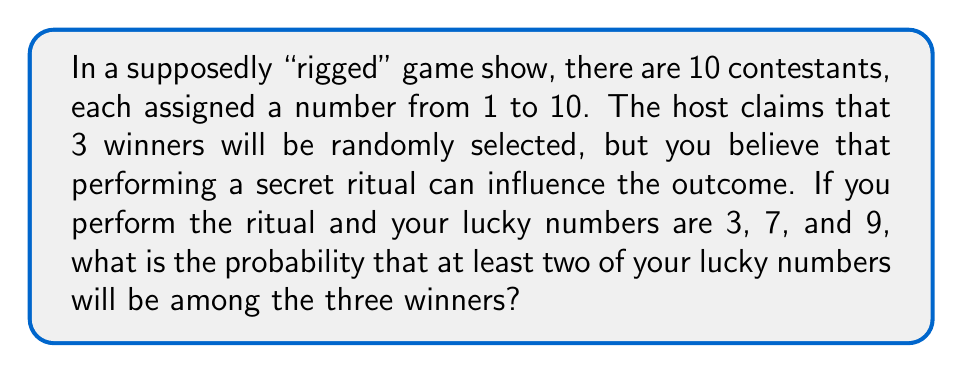Can you answer this question? Let's approach this step-by-step using combinatorics:

1) First, we need to calculate the total number of possible ways to select 3 winners out of 10 contestants. This is given by the combination formula:

   $$\binom{10}{3} = \frac{10!}{3!(10-3)!} = \frac{10!}{3!7!} = 120$$

2) Now, we need to calculate the number of favorable outcomes. There are two cases to consider:
   a) Exactly two of your lucky numbers are selected
   b) All three of your lucky numbers are selected

3) For case a):
   - Choose 2 out of your 3 lucky numbers: $\binom{3}{2} = 3$ ways
   - Choose 1 from the other 7 numbers: $\binom{7}{1} = 7$ ways
   - Total for this case: $3 * 7 = 21$ ways

4) For case b):
   - All 3 of your lucky numbers are selected: $\binom{3}{3} = 1$ way

5) Total favorable outcomes: $21 + 1 = 22$

6) The probability is thus:

   $$P(\text{at least two lucky numbers}) = \frac{\text{favorable outcomes}}{\text{total outcomes}} = \frac{22}{120} = \frac{11}{60}$$

This can be reduced to:

$$P(\text{at least two lucky numbers}) = \frac{11}{60} \approx 0.1833$$
Answer: $\frac{11}{60}$ or approximately $0.1833$ or $18.33\%$ 